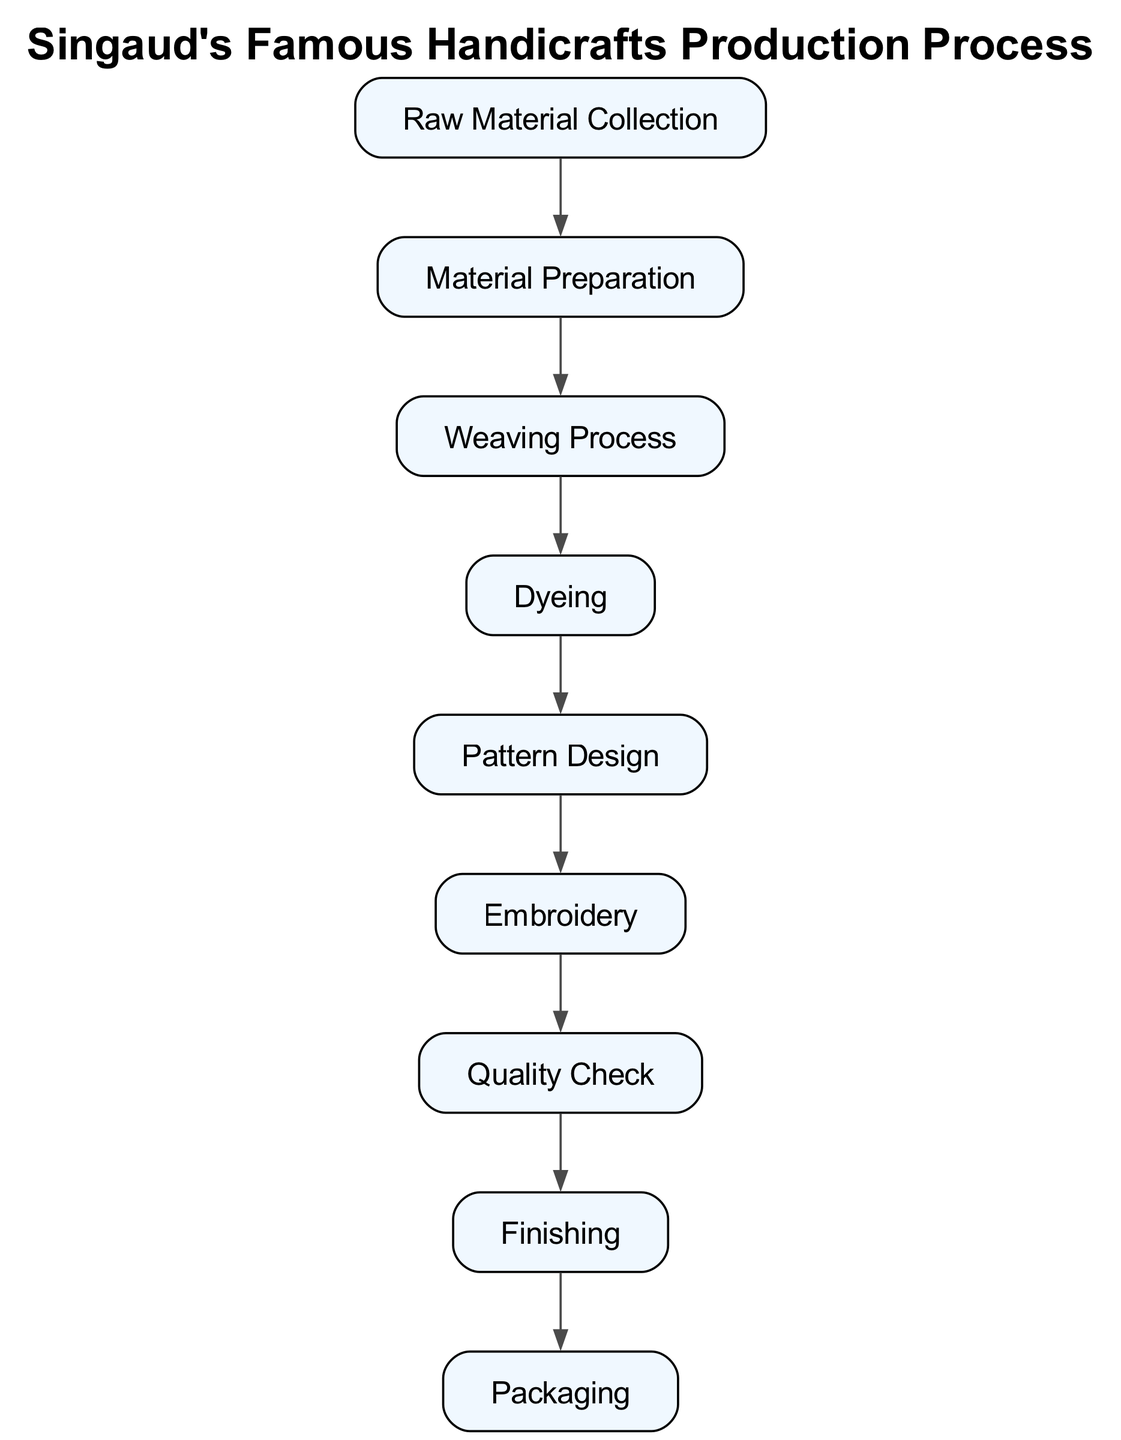What is the first step in the production process? The first step in the diagram is "Raw Material Collection," which is indicated as the starting point with arrows leading to the next process.
Answer: Raw Material Collection How many nodes are in the diagram? By counting each distinct node listed in the diagram, we find there are a total of nine nodes that represent different stages of the production process.
Answer: 9 What comes after "Weaving Process"? Tracing the arrows from "Weaving Process," the next step in the sequence is "Dyeing," as indicated by the directed edge leading from Weaving to Dyeing.
Answer: Dyeing Which step involves adding designs to the fabric? The step associated with adding designs in the production process is "Pattern Design," which follows the Dyeing step in the sequential flow of the diagram.
Answer: Pattern Design What is the final step in the production process? The last stage illustrated in the diagram is "Packaging," which comes after several other processes and is the endpoint of the flow.
Answer: Packaging Which two steps are directly connected? Multiple connections exist, but focusing on "Dyeing" and "Pattern Design," these two steps are directly linked, indicating a sequential process flow between them.
Answer: Dyeing, Pattern Design What is the relationship between "Embroidery" and "Quality Check"? According to the diagram, "Embroidery" leads directly to "Quality Check," showing that Quality Check follows Embroidery in the production process.
Answer: Embroidery → Quality Check How many edges are there in the diagram? By counting the connections (edges) depicted in the diagram that link the nodes together, we find there are a total of eight edges representing the flow between the different steps.
Answer: 8 What process immediately follows "Quality Check"? Following "Quality Check," the next step in the production line, as shown by the directed edge in the diagram, is "Finishing."
Answer: Finishing 